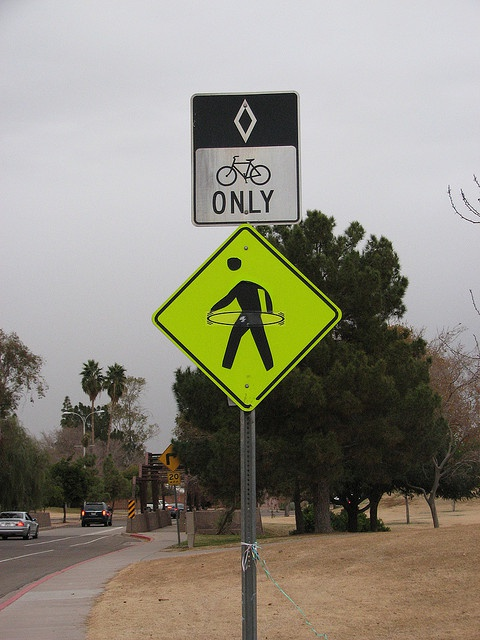Describe the objects in this image and their specific colors. I can see car in darkgray, black, and gray tones, truck in darkgray, black, gray, maroon, and purple tones, car in darkgray, black, and gray tones, truck in darkgray, black, gray, and lightgray tones, and car in darkgray, black, gray, and lightgray tones in this image. 